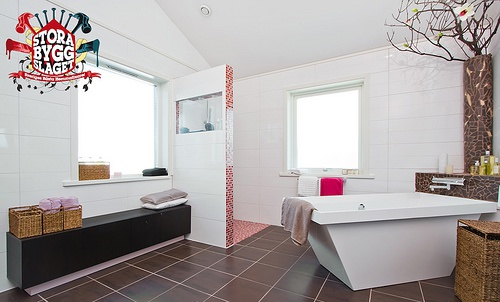Describe the objects in this image and their specific colors. I can see vase in lightgray, brown, maroon, and gray tones, bottle in lightgray, olive, and tan tones, bottle in lightgray, tan, olive, and darkgray tones, bottle in lightgray and tan tones, and bottle in lightgray, darkgray, gray, and tan tones in this image. 